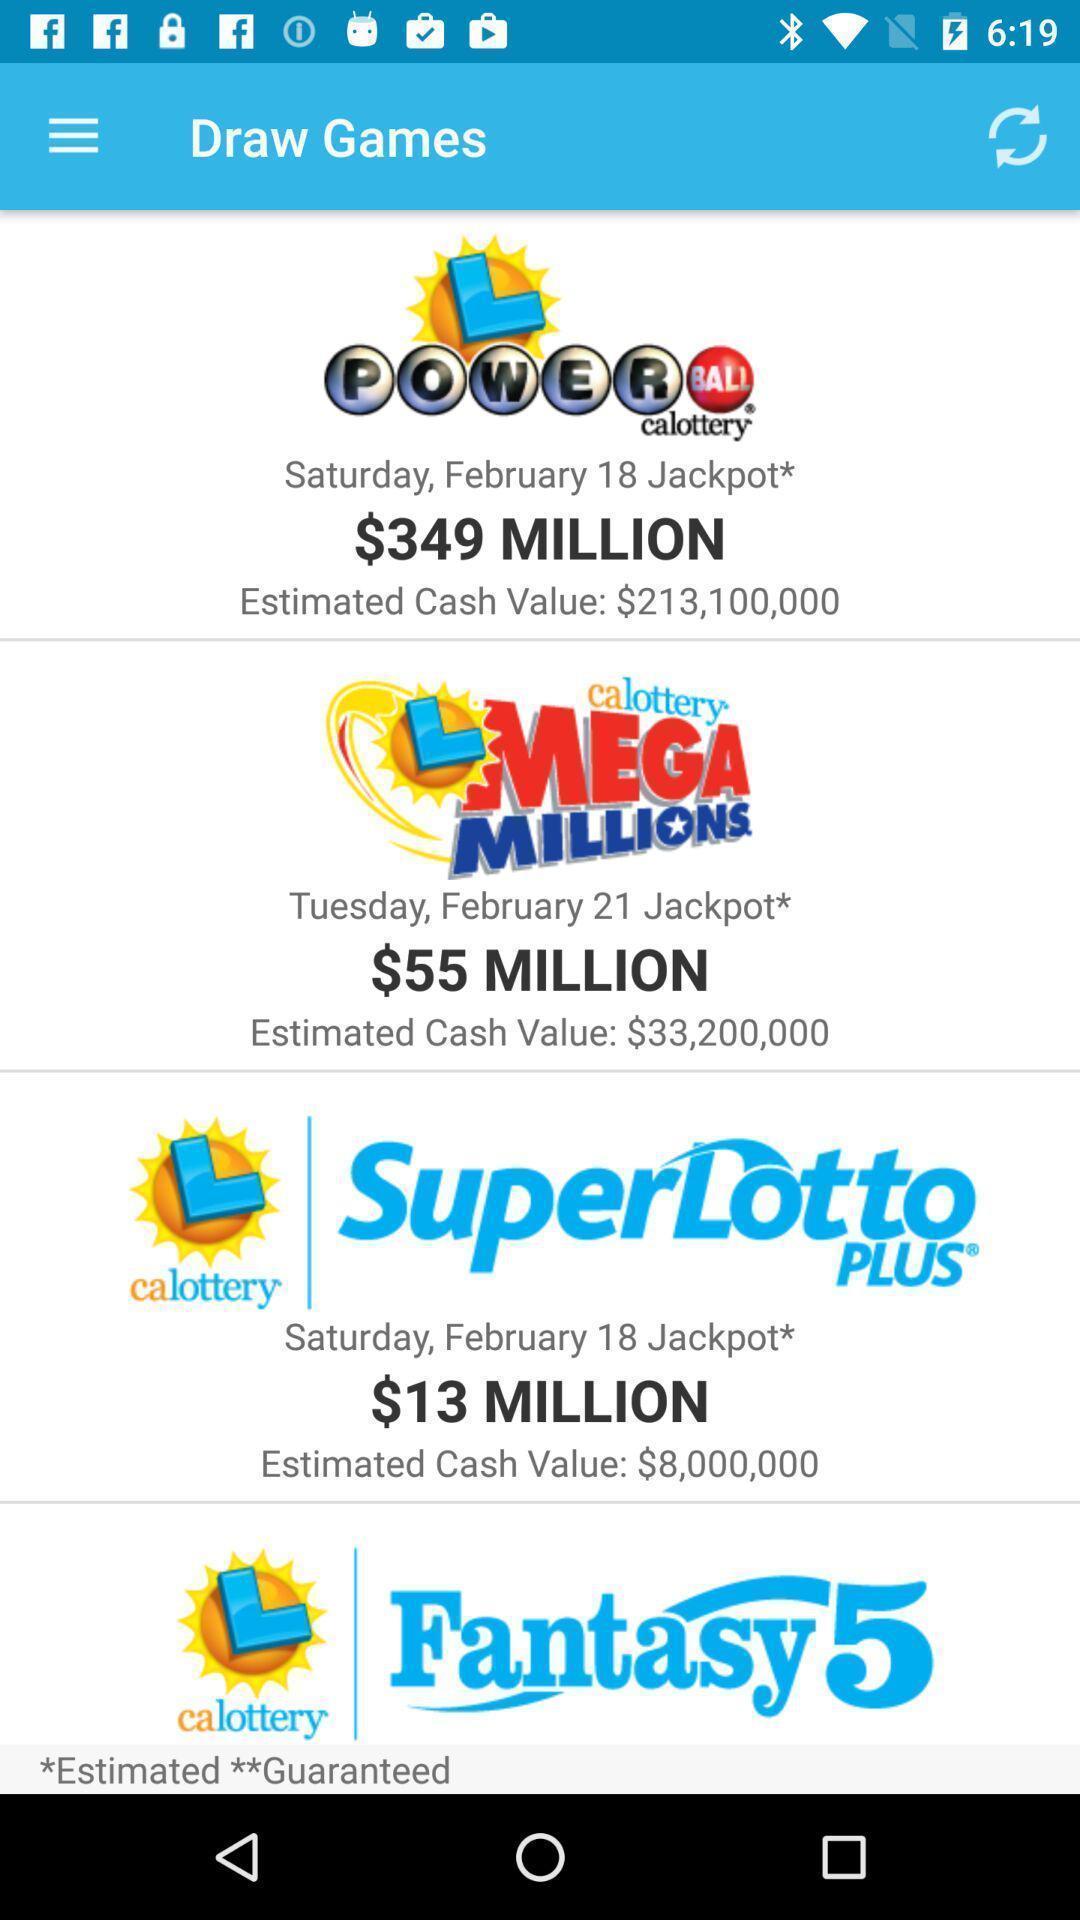Describe this image in words. Page showing different games. 